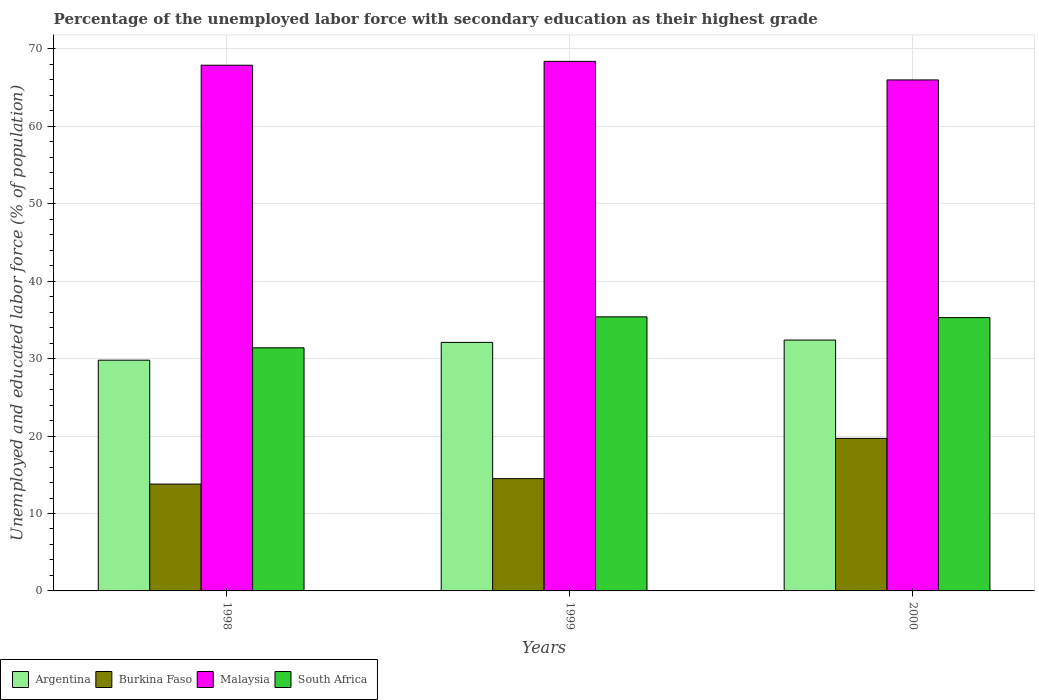How many different coloured bars are there?
Make the answer very short. 4. How many groups of bars are there?
Your answer should be very brief. 3. Are the number of bars on each tick of the X-axis equal?
Make the answer very short. Yes. How many bars are there on the 2nd tick from the left?
Make the answer very short. 4. Across all years, what is the maximum percentage of the unemployed labor force with secondary education in Argentina?
Keep it short and to the point. 32.4. Across all years, what is the minimum percentage of the unemployed labor force with secondary education in South Africa?
Make the answer very short. 31.4. In which year was the percentage of the unemployed labor force with secondary education in Argentina minimum?
Keep it short and to the point. 1998. What is the total percentage of the unemployed labor force with secondary education in Burkina Faso in the graph?
Provide a succinct answer. 48. What is the difference between the percentage of the unemployed labor force with secondary education in Malaysia in 1998 and that in 2000?
Keep it short and to the point. 1.9. What is the average percentage of the unemployed labor force with secondary education in South Africa per year?
Provide a succinct answer. 34.03. In the year 2000, what is the difference between the percentage of the unemployed labor force with secondary education in South Africa and percentage of the unemployed labor force with secondary education in Malaysia?
Provide a succinct answer. -30.7. What is the ratio of the percentage of the unemployed labor force with secondary education in Malaysia in 1998 to that in 2000?
Ensure brevity in your answer.  1.03. Is the difference between the percentage of the unemployed labor force with secondary education in South Africa in 1998 and 1999 greater than the difference between the percentage of the unemployed labor force with secondary education in Malaysia in 1998 and 1999?
Your answer should be very brief. No. What is the difference between the highest and the second highest percentage of the unemployed labor force with secondary education in Malaysia?
Make the answer very short. 0.5. What is the difference between the highest and the lowest percentage of the unemployed labor force with secondary education in South Africa?
Offer a terse response. 4. Is the sum of the percentage of the unemployed labor force with secondary education in South Africa in 1998 and 1999 greater than the maximum percentage of the unemployed labor force with secondary education in Argentina across all years?
Your answer should be very brief. Yes. What does the 3rd bar from the left in 1998 represents?
Offer a very short reply. Malaysia. What does the 2nd bar from the right in 1998 represents?
Your response must be concise. Malaysia. Is it the case that in every year, the sum of the percentage of the unemployed labor force with secondary education in South Africa and percentage of the unemployed labor force with secondary education in Burkina Faso is greater than the percentage of the unemployed labor force with secondary education in Malaysia?
Offer a very short reply. No. Are all the bars in the graph horizontal?
Give a very brief answer. No. How many years are there in the graph?
Your answer should be compact. 3. Does the graph contain grids?
Provide a short and direct response. Yes. How many legend labels are there?
Give a very brief answer. 4. How are the legend labels stacked?
Your answer should be very brief. Horizontal. What is the title of the graph?
Make the answer very short. Percentage of the unemployed labor force with secondary education as their highest grade. Does "Samoa" appear as one of the legend labels in the graph?
Provide a short and direct response. No. What is the label or title of the X-axis?
Offer a very short reply. Years. What is the label or title of the Y-axis?
Your answer should be very brief. Unemployed and educated labor force (% of population). What is the Unemployed and educated labor force (% of population) in Argentina in 1998?
Offer a terse response. 29.8. What is the Unemployed and educated labor force (% of population) of Burkina Faso in 1998?
Make the answer very short. 13.8. What is the Unemployed and educated labor force (% of population) in Malaysia in 1998?
Your answer should be compact. 67.9. What is the Unemployed and educated labor force (% of population) of South Africa in 1998?
Give a very brief answer. 31.4. What is the Unemployed and educated labor force (% of population) in Argentina in 1999?
Ensure brevity in your answer.  32.1. What is the Unemployed and educated labor force (% of population) of Malaysia in 1999?
Your answer should be very brief. 68.4. What is the Unemployed and educated labor force (% of population) in South Africa in 1999?
Provide a short and direct response. 35.4. What is the Unemployed and educated labor force (% of population) in Argentina in 2000?
Offer a terse response. 32.4. What is the Unemployed and educated labor force (% of population) of Burkina Faso in 2000?
Offer a terse response. 19.7. What is the Unemployed and educated labor force (% of population) in Malaysia in 2000?
Provide a short and direct response. 66. What is the Unemployed and educated labor force (% of population) of South Africa in 2000?
Offer a very short reply. 35.3. Across all years, what is the maximum Unemployed and educated labor force (% of population) of Argentina?
Provide a short and direct response. 32.4. Across all years, what is the maximum Unemployed and educated labor force (% of population) in Burkina Faso?
Give a very brief answer. 19.7. Across all years, what is the maximum Unemployed and educated labor force (% of population) of Malaysia?
Your response must be concise. 68.4. Across all years, what is the maximum Unemployed and educated labor force (% of population) of South Africa?
Give a very brief answer. 35.4. Across all years, what is the minimum Unemployed and educated labor force (% of population) of Argentina?
Your answer should be compact. 29.8. Across all years, what is the minimum Unemployed and educated labor force (% of population) in Burkina Faso?
Ensure brevity in your answer.  13.8. Across all years, what is the minimum Unemployed and educated labor force (% of population) in Malaysia?
Give a very brief answer. 66. Across all years, what is the minimum Unemployed and educated labor force (% of population) of South Africa?
Your answer should be very brief. 31.4. What is the total Unemployed and educated labor force (% of population) of Argentina in the graph?
Provide a succinct answer. 94.3. What is the total Unemployed and educated labor force (% of population) in Burkina Faso in the graph?
Your answer should be very brief. 48. What is the total Unemployed and educated labor force (% of population) in Malaysia in the graph?
Your answer should be very brief. 202.3. What is the total Unemployed and educated labor force (% of population) in South Africa in the graph?
Your response must be concise. 102.1. What is the difference between the Unemployed and educated labor force (% of population) of South Africa in 1998 and that in 1999?
Provide a succinct answer. -4. What is the difference between the Unemployed and educated labor force (% of population) of Argentina in 1998 and that in 2000?
Make the answer very short. -2.6. What is the difference between the Unemployed and educated labor force (% of population) in Burkina Faso in 1998 and that in 2000?
Provide a succinct answer. -5.9. What is the difference between the Unemployed and educated labor force (% of population) of Malaysia in 1998 and that in 2000?
Make the answer very short. 1.9. What is the difference between the Unemployed and educated labor force (% of population) of Argentina in 1999 and that in 2000?
Ensure brevity in your answer.  -0.3. What is the difference between the Unemployed and educated labor force (% of population) in South Africa in 1999 and that in 2000?
Make the answer very short. 0.1. What is the difference between the Unemployed and educated labor force (% of population) in Argentina in 1998 and the Unemployed and educated labor force (% of population) in Burkina Faso in 1999?
Provide a succinct answer. 15.3. What is the difference between the Unemployed and educated labor force (% of population) of Argentina in 1998 and the Unemployed and educated labor force (% of population) of Malaysia in 1999?
Offer a terse response. -38.6. What is the difference between the Unemployed and educated labor force (% of population) of Burkina Faso in 1998 and the Unemployed and educated labor force (% of population) of Malaysia in 1999?
Your response must be concise. -54.6. What is the difference between the Unemployed and educated labor force (% of population) in Burkina Faso in 1998 and the Unemployed and educated labor force (% of population) in South Africa in 1999?
Ensure brevity in your answer.  -21.6. What is the difference between the Unemployed and educated labor force (% of population) in Malaysia in 1998 and the Unemployed and educated labor force (% of population) in South Africa in 1999?
Your response must be concise. 32.5. What is the difference between the Unemployed and educated labor force (% of population) of Argentina in 1998 and the Unemployed and educated labor force (% of population) of Burkina Faso in 2000?
Make the answer very short. 10.1. What is the difference between the Unemployed and educated labor force (% of population) in Argentina in 1998 and the Unemployed and educated labor force (% of population) in Malaysia in 2000?
Give a very brief answer. -36.2. What is the difference between the Unemployed and educated labor force (% of population) in Burkina Faso in 1998 and the Unemployed and educated labor force (% of population) in Malaysia in 2000?
Give a very brief answer. -52.2. What is the difference between the Unemployed and educated labor force (% of population) in Burkina Faso in 1998 and the Unemployed and educated labor force (% of population) in South Africa in 2000?
Offer a very short reply. -21.5. What is the difference between the Unemployed and educated labor force (% of population) in Malaysia in 1998 and the Unemployed and educated labor force (% of population) in South Africa in 2000?
Your answer should be compact. 32.6. What is the difference between the Unemployed and educated labor force (% of population) in Argentina in 1999 and the Unemployed and educated labor force (% of population) in Burkina Faso in 2000?
Your response must be concise. 12.4. What is the difference between the Unemployed and educated labor force (% of population) in Argentina in 1999 and the Unemployed and educated labor force (% of population) in Malaysia in 2000?
Provide a short and direct response. -33.9. What is the difference between the Unemployed and educated labor force (% of population) of Argentina in 1999 and the Unemployed and educated labor force (% of population) of South Africa in 2000?
Ensure brevity in your answer.  -3.2. What is the difference between the Unemployed and educated labor force (% of population) of Burkina Faso in 1999 and the Unemployed and educated labor force (% of population) of Malaysia in 2000?
Provide a short and direct response. -51.5. What is the difference between the Unemployed and educated labor force (% of population) in Burkina Faso in 1999 and the Unemployed and educated labor force (% of population) in South Africa in 2000?
Your answer should be very brief. -20.8. What is the difference between the Unemployed and educated labor force (% of population) in Malaysia in 1999 and the Unemployed and educated labor force (% of population) in South Africa in 2000?
Your answer should be compact. 33.1. What is the average Unemployed and educated labor force (% of population) in Argentina per year?
Ensure brevity in your answer.  31.43. What is the average Unemployed and educated labor force (% of population) of Malaysia per year?
Offer a terse response. 67.43. What is the average Unemployed and educated labor force (% of population) of South Africa per year?
Keep it short and to the point. 34.03. In the year 1998, what is the difference between the Unemployed and educated labor force (% of population) of Argentina and Unemployed and educated labor force (% of population) of Burkina Faso?
Give a very brief answer. 16. In the year 1998, what is the difference between the Unemployed and educated labor force (% of population) of Argentina and Unemployed and educated labor force (% of population) of Malaysia?
Your answer should be very brief. -38.1. In the year 1998, what is the difference between the Unemployed and educated labor force (% of population) in Burkina Faso and Unemployed and educated labor force (% of population) in Malaysia?
Ensure brevity in your answer.  -54.1. In the year 1998, what is the difference between the Unemployed and educated labor force (% of population) of Burkina Faso and Unemployed and educated labor force (% of population) of South Africa?
Your response must be concise. -17.6. In the year 1998, what is the difference between the Unemployed and educated labor force (% of population) of Malaysia and Unemployed and educated labor force (% of population) of South Africa?
Offer a terse response. 36.5. In the year 1999, what is the difference between the Unemployed and educated labor force (% of population) in Argentina and Unemployed and educated labor force (% of population) in Burkina Faso?
Provide a short and direct response. 17.6. In the year 1999, what is the difference between the Unemployed and educated labor force (% of population) in Argentina and Unemployed and educated labor force (% of population) in Malaysia?
Provide a short and direct response. -36.3. In the year 1999, what is the difference between the Unemployed and educated labor force (% of population) in Burkina Faso and Unemployed and educated labor force (% of population) in Malaysia?
Your answer should be very brief. -53.9. In the year 1999, what is the difference between the Unemployed and educated labor force (% of population) in Burkina Faso and Unemployed and educated labor force (% of population) in South Africa?
Keep it short and to the point. -20.9. In the year 2000, what is the difference between the Unemployed and educated labor force (% of population) in Argentina and Unemployed and educated labor force (% of population) in Malaysia?
Provide a short and direct response. -33.6. In the year 2000, what is the difference between the Unemployed and educated labor force (% of population) in Burkina Faso and Unemployed and educated labor force (% of population) in Malaysia?
Give a very brief answer. -46.3. In the year 2000, what is the difference between the Unemployed and educated labor force (% of population) of Burkina Faso and Unemployed and educated labor force (% of population) of South Africa?
Provide a succinct answer. -15.6. In the year 2000, what is the difference between the Unemployed and educated labor force (% of population) of Malaysia and Unemployed and educated labor force (% of population) of South Africa?
Your response must be concise. 30.7. What is the ratio of the Unemployed and educated labor force (% of population) in Argentina in 1998 to that in 1999?
Make the answer very short. 0.93. What is the ratio of the Unemployed and educated labor force (% of population) of Burkina Faso in 1998 to that in 1999?
Offer a terse response. 0.95. What is the ratio of the Unemployed and educated labor force (% of population) in Malaysia in 1998 to that in 1999?
Offer a very short reply. 0.99. What is the ratio of the Unemployed and educated labor force (% of population) in South Africa in 1998 to that in 1999?
Your answer should be very brief. 0.89. What is the ratio of the Unemployed and educated labor force (% of population) of Argentina in 1998 to that in 2000?
Provide a short and direct response. 0.92. What is the ratio of the Unemployed and educated labor force (% of population) of Burkina Faso in 1998 to that in 2000?
Ensure brevity in your answer.  0.7. What is the ratio of the Unemployed and educated labor force (% of population) of Malaysia in 1998 to that in 2000?
Your answer should be compact. 1.03. What is the ratio of the Unemployed and educated labor force (% of population) of South Africa in 1998 to that in 2000?
Keep it short and to the point. 0.89. What is the ratio of the Unemployed and educated labor force (% of population) of Burkina Faso in 1999 to that in 2000?
Your response must be concise. 0.74. What is the ratio of the Unemployed and educated labor force (% of population) of Malaysia in 1999 to that in 2000?
Make the answer very short. 1.04. What is the difference between the highest and the second highest Unemployed and educated labor force (% of population) of Argentina?
Ensure brevity in your answer.  0.3. What is the difference between the highest and the second highest Unemployed and educated labor force (% of population) of Burkina Faso?
Offer a very short reply. 5.2. What is the difference between the highest and the second highest Unemployed and educated labor force (% of population) of Malaysia?
Offer a terse response. 0.5. What is the difference between the highest and the second highest Unemployed and educated labor force (% of population) in South Africa?
Offer a terse response. 0.1. What is the difference between the highest and the lowest Unemployed and educated labor force (% of population) of Argentina?
Keep it short and to the point. 2.6. What is the difference between the highest and the lowest Unemployed and educated labor force (% of population) in Malaysia?
Offer a very short reply. 2.4. 